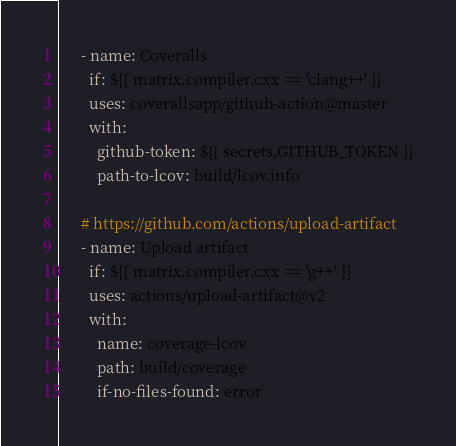<code> <loc_0><loc_0><loc_500><loc_500><_YAML_>      - name: Coveralls
        if: ${{ matrix.compiler.cxx == 'clang++' }}
        uses: coverallsapp/github-action@master
        with:
          github-token: ${{ secrets.GITHUB_TOKEN }}
          path-to-lcov: build/lcov.info

      # https://github.com/actions/upload-artifact
      - name: Upload artifact
        if: ${{ matrix.compiler.cxx == 'g++' }}
        uses: actions/upload-artifact@v2
        with:
          name: coverage-lcov
          path: build/coverage
          if-no-files-found: error
</code> 